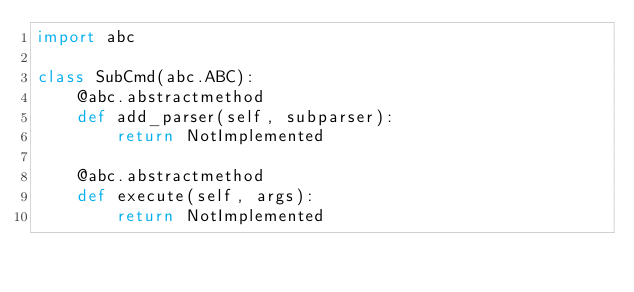Convert code to text. <code><loc_0><loc_0><loc_500><loc_500><_Python_>import abc

class SubCmd(abc.ABC):
    @abc.abstractmethod
    def add_parser(self, subparser):
        return NotImplemented

    @abc.abstractmethod
    def execute(self, args):
        return NotImplemented
</code> 